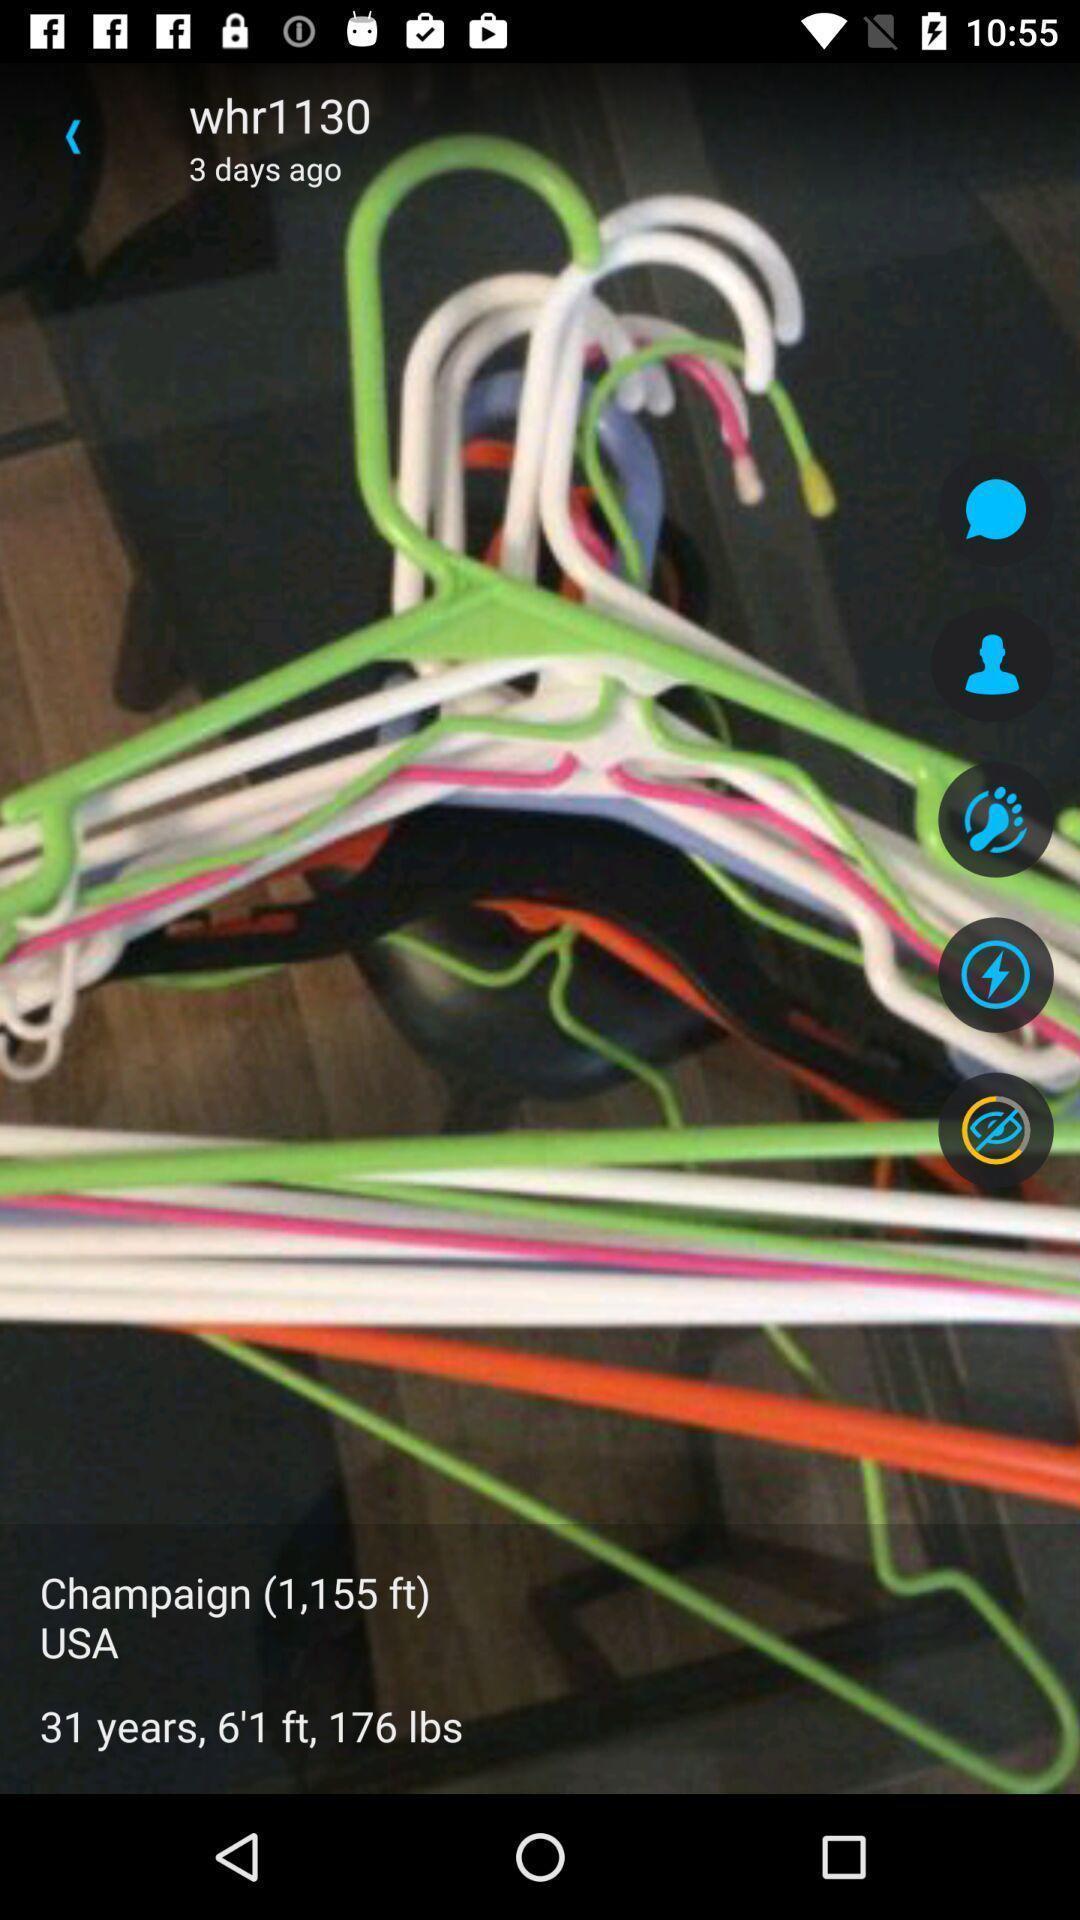Describe the key features of this screenshot. Page of an social application with options. 